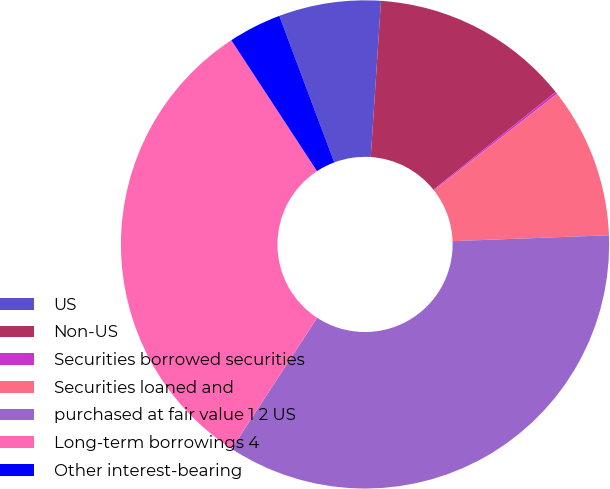<chart> <loc_0><loc_0><loc_500><loc_500><pie_chart><fcel>US<fcel>Non-US<fcel>Securities borrowed securities<fcel>Securities loaned and<fcel>purchased at fair value 1 2 US<fcel>Long-term borrowings 4<fcel>Other interest-bearing<nl><fcel>6.75%<fcel>13.22%<fcel>0.15%<fcel>9.99%<fcel>34.8%<fcel>31.57%<fcel>3.52%<nl></chart> 